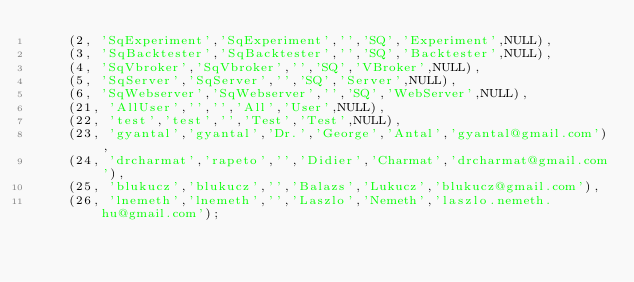<code> <loc_0><loc_0><loc_500><loc_500><_SQL_>	(2, 'SqExperiment','SqExperiment','','SQ','Experiment',NULL),
	(3, 'SqBacktester','SqBacktester','','SQ','Backtester',NULL),
	(4, 'SqVbroker','SqVbroker','','SQ','VBroker',NULL),
	(5, 'SqServer','SqServer','','SQ','Server',NULL),
	(6, 'SqWebserver','SqWebserver','','SQ','WebServer',NULL),
	(21, 'AllUser','','','All','User',NULL),
	(22, 'test','test','','Test','Test',NULL),
	(23, 'gyantal','gyantal','Dr.','George','Antal','gyantal@gmail.com'),
	(24, 'drcharmat','rapeto','','Didier','Charmat','drcharmat@gmail.com'),
	(25, 'blukucz','blukucz','','Balazs','Lukucz','blukucz@gmail.com'),
	(26, 'lnemeth','lnemeth','','Laszlo','Nemeth','laszlo.nemeth.hu@gmail.com');


</code> 